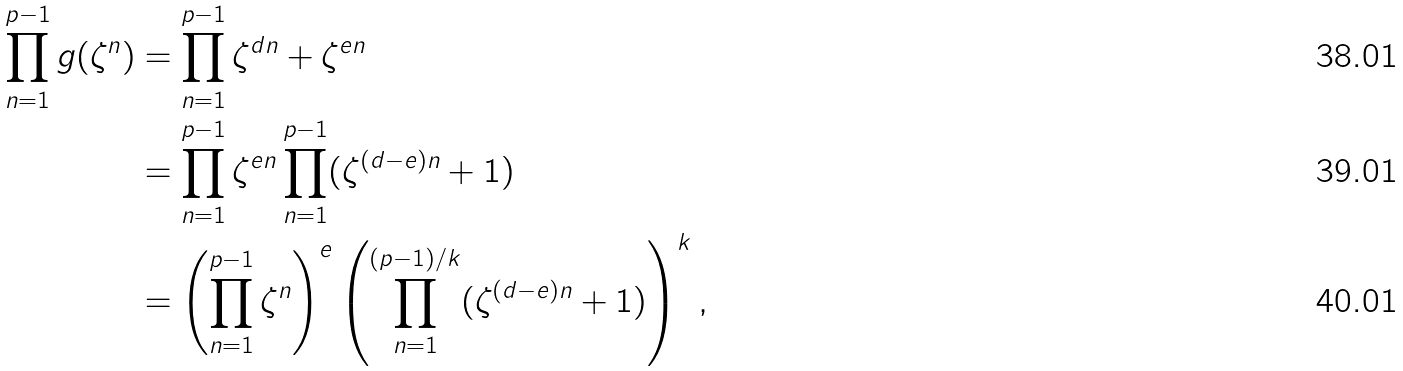Convert formula to latex. <formula><loc_0><loc_0><loc_500><loc_500>\prod _ { n = 1 } ^ { p - 1 } g ( \zeta ^ { n } ) & = \prod _ { n = 1 } ^ { p - 1 } \zeta ^ { d n } + \zeta ^ { e n } \\ & = \prod _ { n = 1 } ^ { p - 1 } \zeta ^ { e n } \prod _ { n = 1 } ^ { p - 1 } ( \zeta ^ { ( d - e ) n } + 1 ) \\ & = \left ( \prod _ { n = 1 } ^ { p - 1 } \zeta ^ { n } \right ) ^ { e } \left ( \prod _ { n = 1 } ^ { ( p - 1 ) / k } ( \zeta ^ { ( d - e ) n } + 1 ) \right ) ^ { k } ,</formula> 